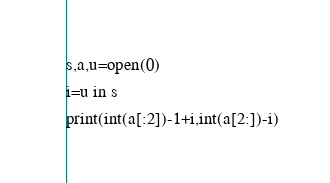<code> <loc_0><loc_0><loc_500><loc_500><_Cython_>s,a,u=open(0)
i=u in s
print(int(a[:2])-1+i,int(a[2:])-i)</code> 